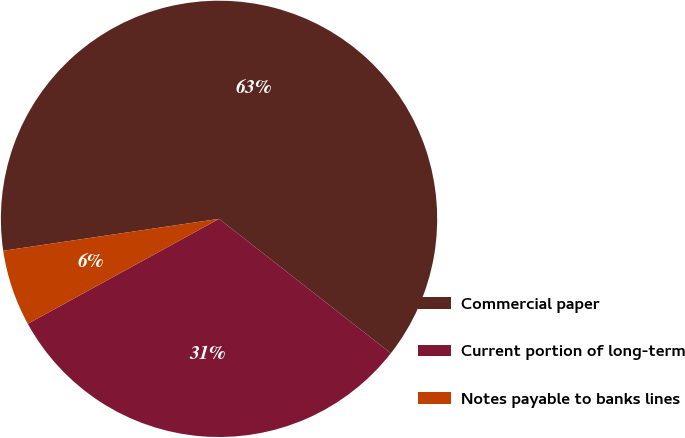Convert chart. <chart><loc_0><loc_0><loc_500><loc_500><pie_chart><fcel>Commercial paper<fcel>Current portion of long-term<fcel>Notes payable to banks lines<nl><fcel>62.9%<fcel>31.45%<fcel>5.65%<nl></chart> 